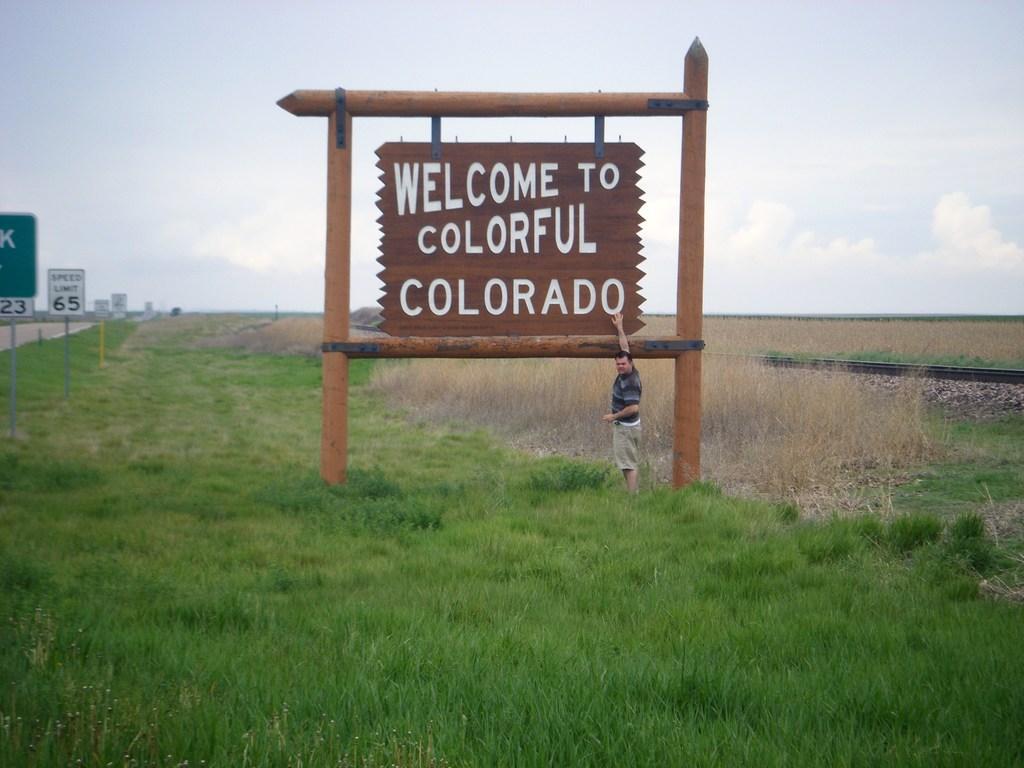Can you describe this image briefly? There is one man standing on a grassy land as we can see at the bottom of this image, and there is a sign board in the middle of this image, and on the left side of this image as well. There is a sky at the top of this image. 